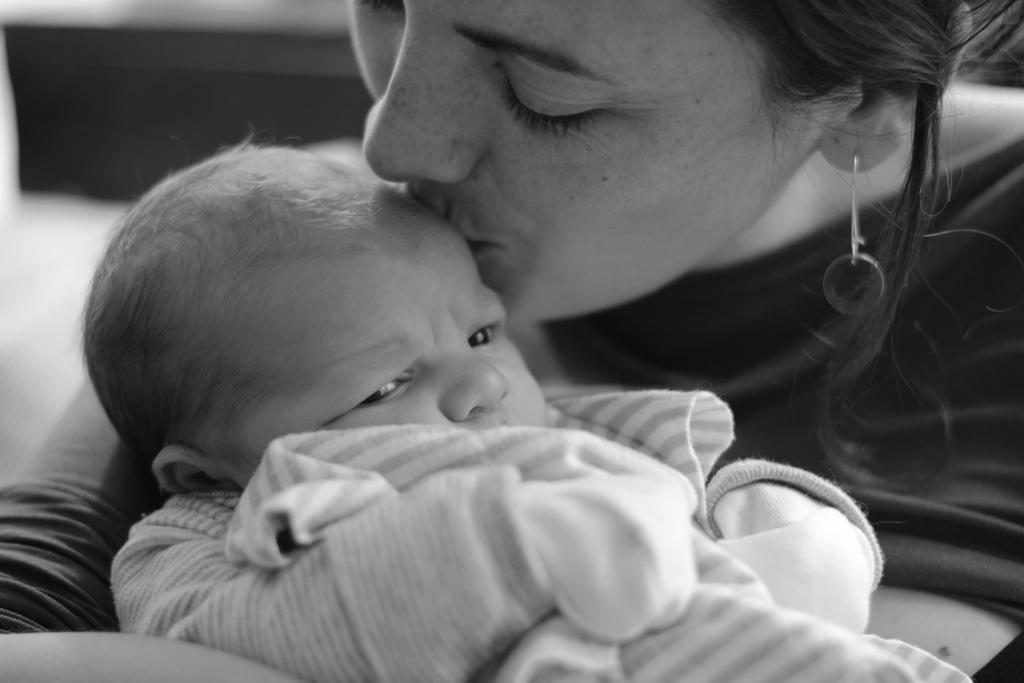Describe this image in one or two sentences. In this image we can see a woman kissing a baby. 